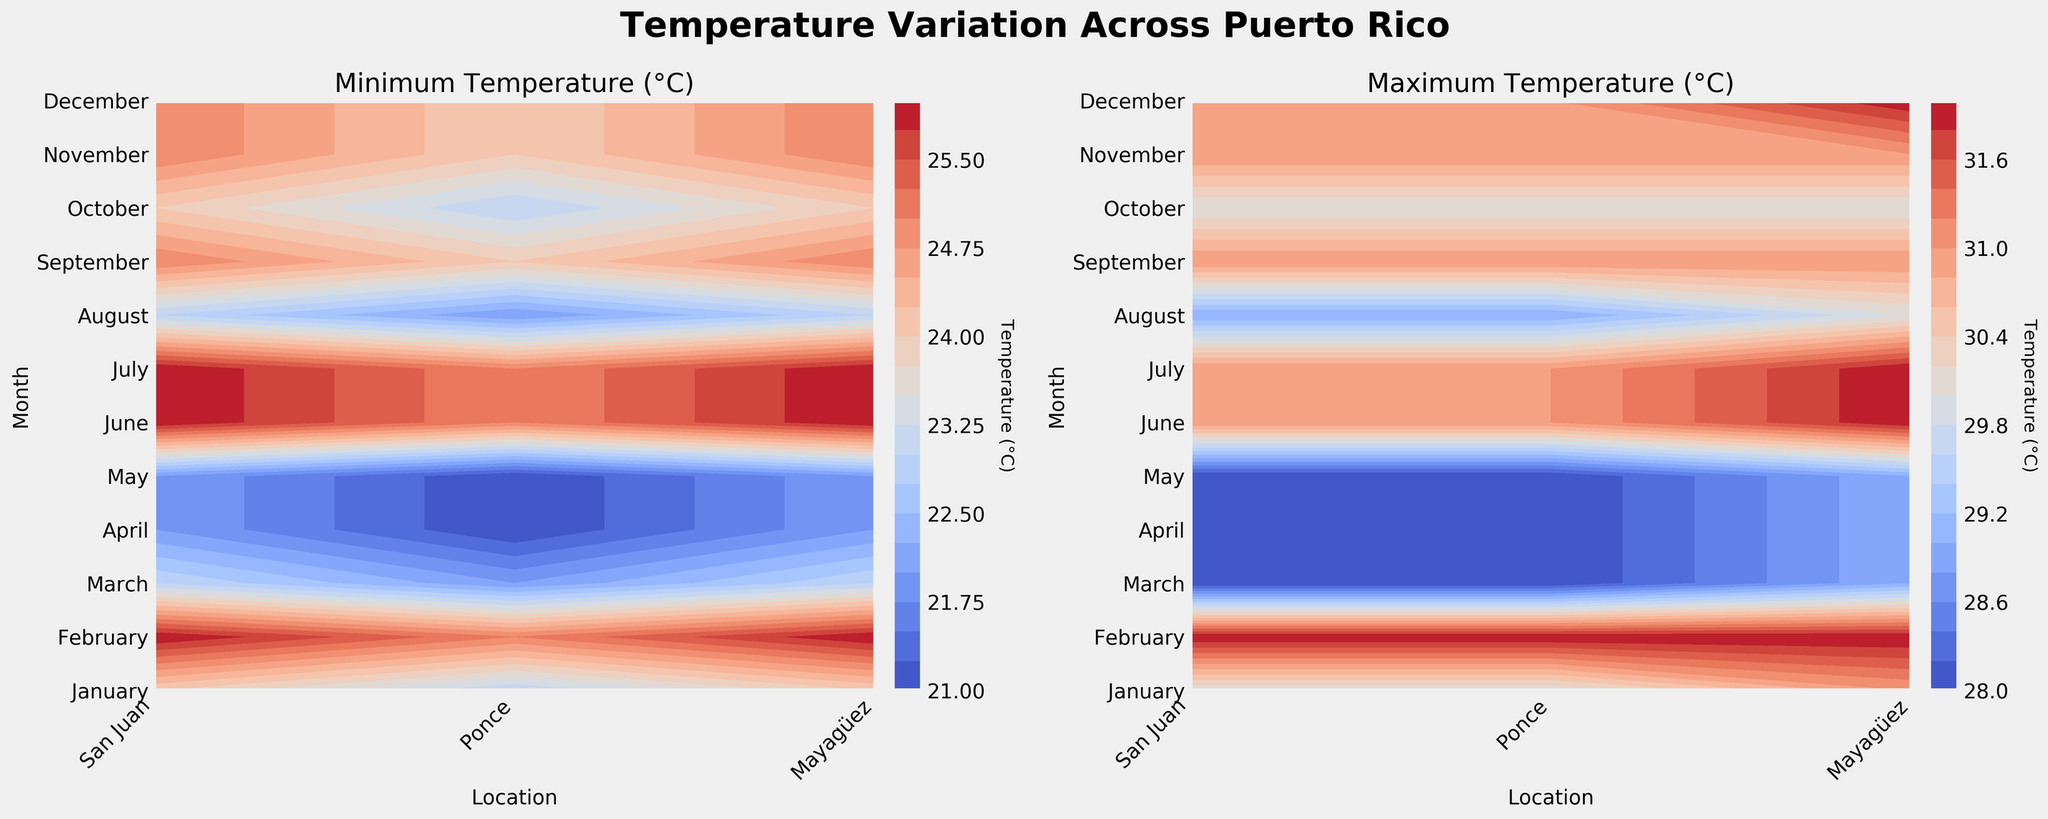What's the title of the figure? The title of the figure is located at the top center of the plot and generally describes the overall content of the figure.
Answer: Temperature Variation Across Puerto Rico What's the x-axis label for both subplots? The x-axis label is seen horizontally below each subplot and indicates the parameter represented on the horizontal axis.
Answer: Location What's the y-axis label for both subplots? The y-axis label is seen vertically to the left of each subplot and indicates the parameter represented on the vertical axis.
Answer: Month Which location has the highest minimum temperature in August? To find this, locate August on the y-axis of the subplot for minimum temperature, and trace it horizontally to find the highest contour level. The highest value is around Mayagüez and San Juan.
Answer: Mayagüez and San Juan What are the approximate minimum and maximum temperatures in San Juan in July? To determine this, find July on the y-axis and San Juan on the x-axis of both subplots. For the minimum temperature subplot, it's around 26°C, and for the maximum temperature subplot, it's around 32°C.
Answer: 26°C (min), 32°C (max) Which month experiences the greatest range of temperatures in Ponce? The range is calculated by subtracting the minimum temperature from the maximum temperature for each month in Ponce. By checking the contour levels in Ponce for each month in both subplots, June to August each show a range from roughly 25°C to 32°C, a 7°C range.
Answer: June, July, August In which months is the minimum temperature almost the same across all locations? By looking at the contours in the minimum temperature subplot vertically and noticing consistent levels across locations, January to March show similar values (around 22°C).
Answer: January, February, March How does the max temperature in Mayagüez in December compare with San Juan's max temperature in December? Find December on the y-axis and compare the contour levels for Mayagüez and San Juan in the max temperature subplot. Both are roughly the same around 28-29°C.
Answer: Roughly the same Is there a month where the minimum temperature exceeds 25°C for every location? Check the minimum temperature subplot for contours above 25°C for all locations. June to September show a minimum of around 25°C.
Answer: June to September How does the temperature variation trend throughout the year? Understanding the trend involves observing the variations in contour levels vertically from January to December. Generally, temperatures rise towards the middle of the year and drop again towards the end.
Answer: Rises in mid-year, drops towards end 